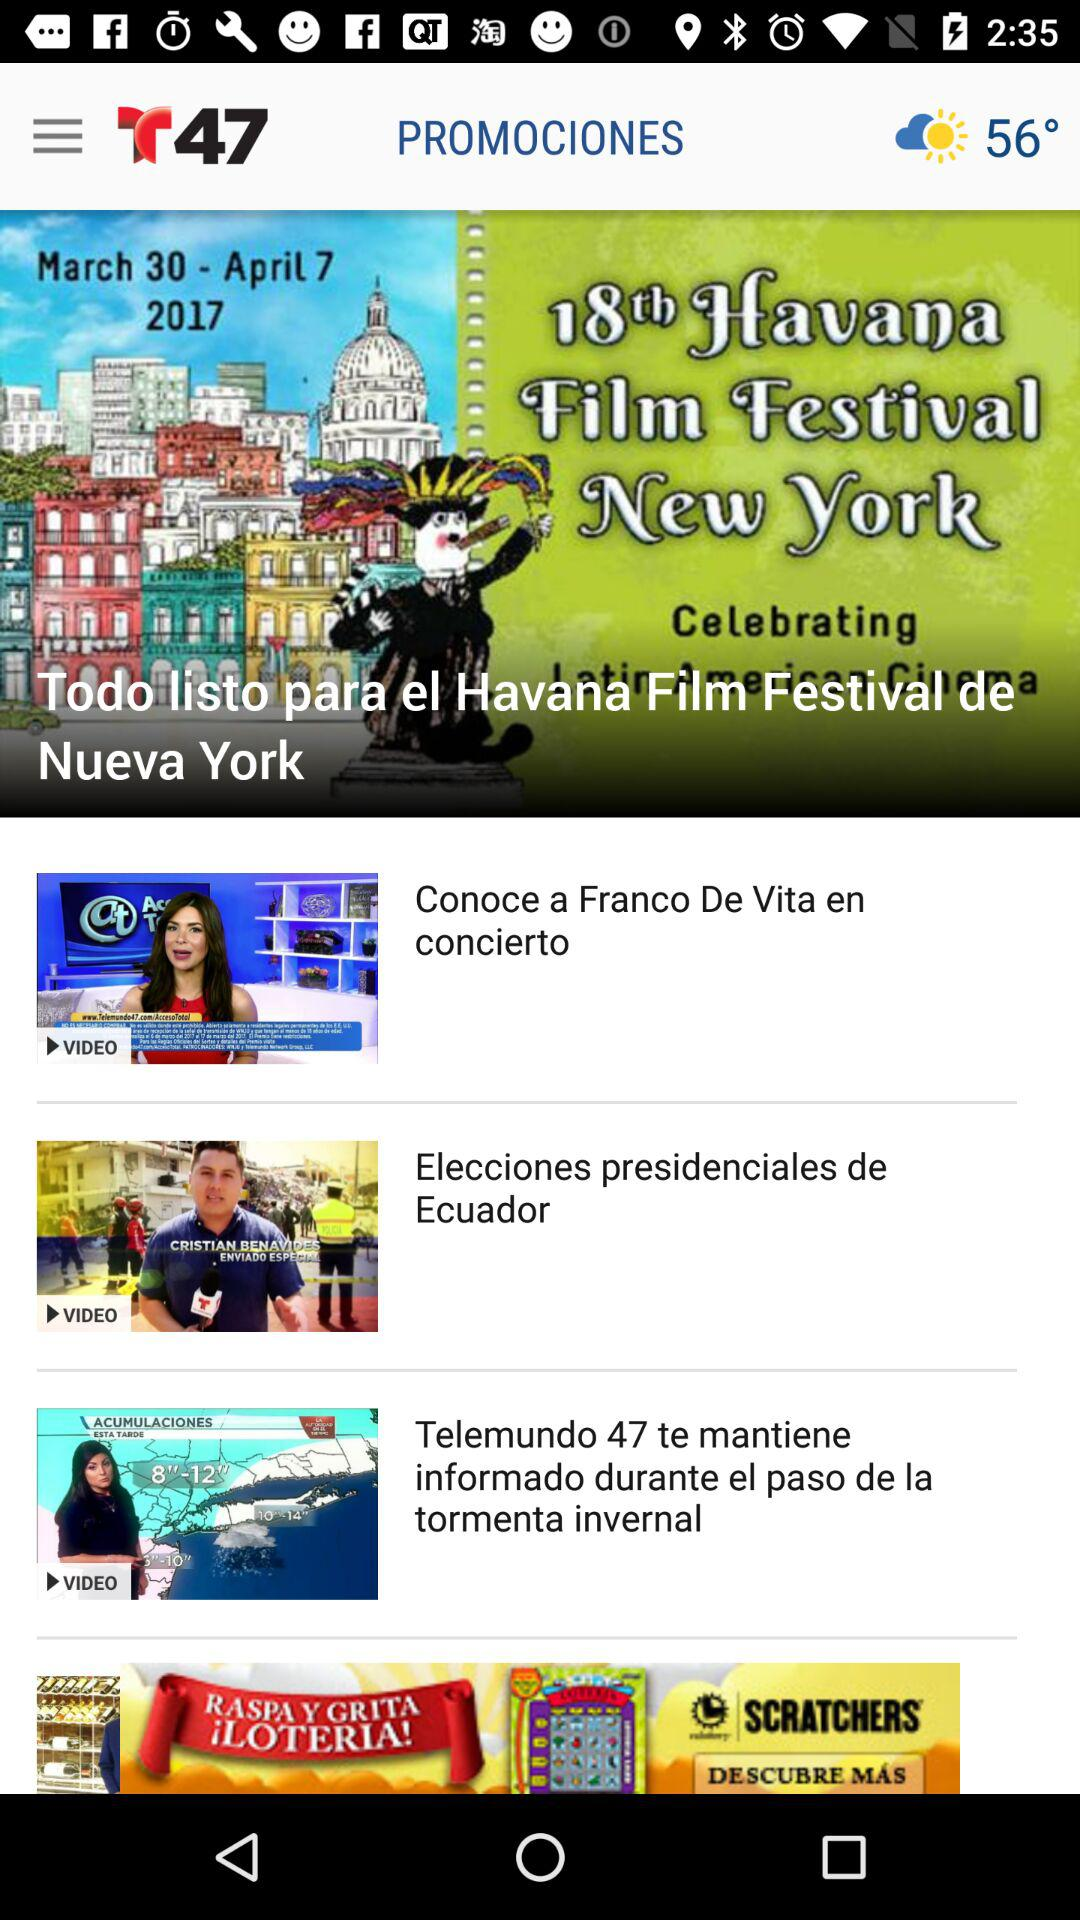How many degrees is the weather?
Answer the question using a single word or phrase. 56° 